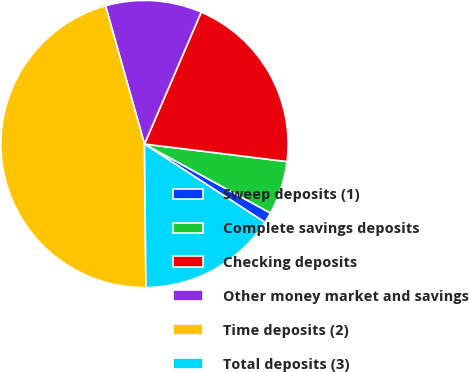Convert chart to OTSL. <chart><loc_0><loc_0><loc_500><loc_500><pie_chart><fcel>Sweep deposits (1)<fcel>Complete savings deposits<fcel>Checking deposits<fcel>Other money market and savings<fcel>Time deposits (2)<fcel>Total deposits (3)<nl><fcel>1.2%<fcel>6.02%<fcel>20.48%<fcel>10.84%<fcel>45.78%<fcel>15.66%<nl></chart> 